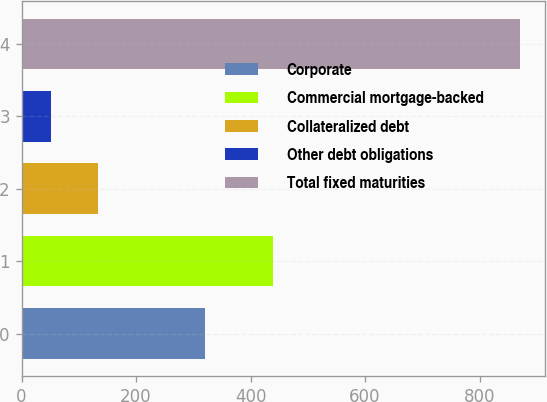Convert chart to OTSL. <chart><loc_0><loc_0><loc_500><loc_500><bar_chart><fcel>Corporate<fcel>Commercial mortgage-backed<fcel>Collateralized debt<fcel>Other debt obligations<fcel>Total fixed maturities<nl><fcel>319.9<fcel>439.1<fcel>133.19<fcel>51.2<fcel>871.1<nl></chart> 